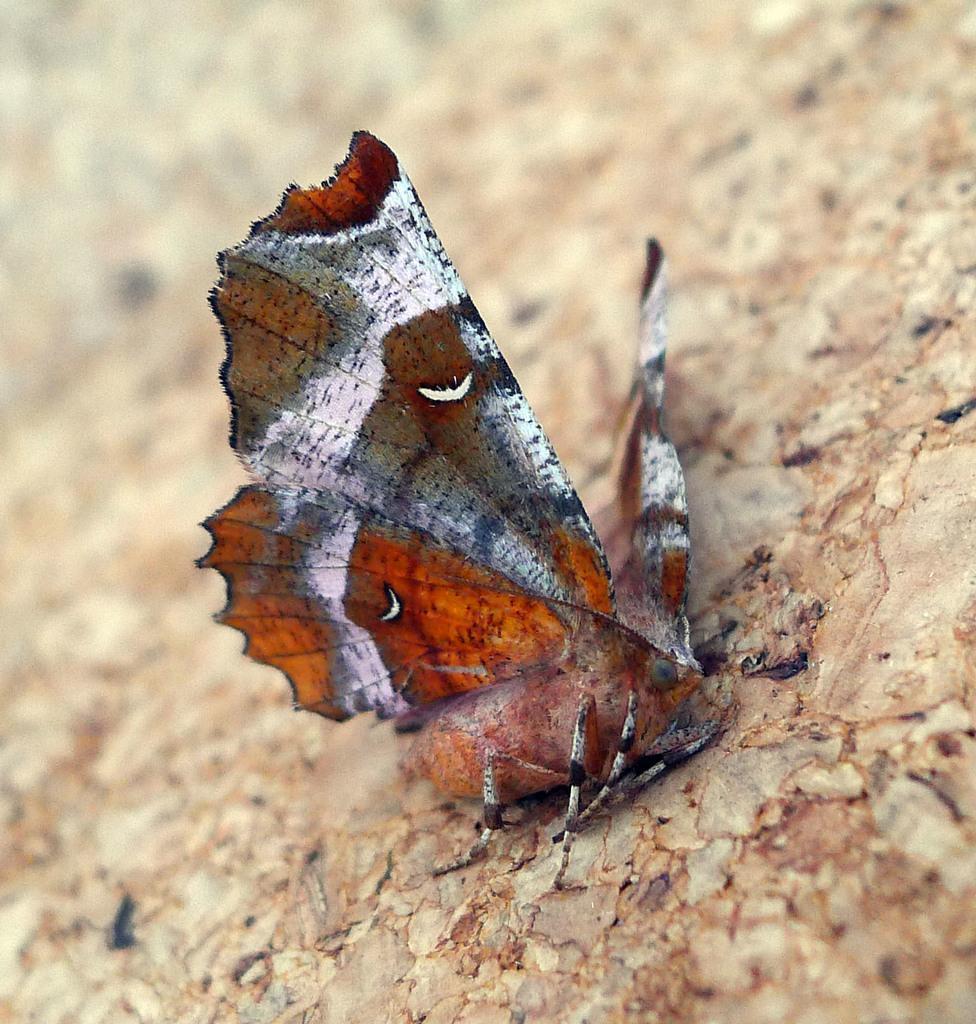Please provide a concise description of this image. In this image there is a butterfly on the rock. 